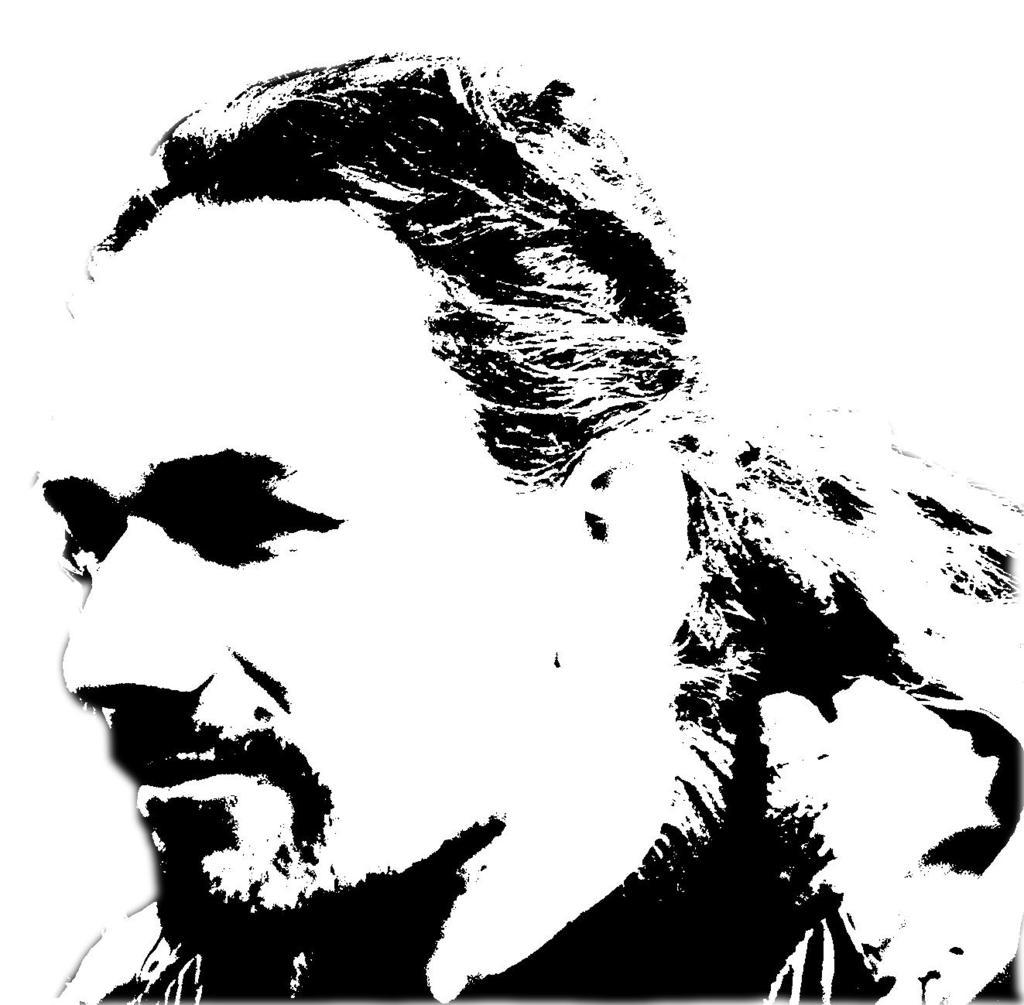What type of editing has been done to the image? The image is edited, but the specific type of editing is not mentioned in the facts. What is the main subject of the image? There is a black and white picture of a man in the image. How many kittens are playing in the trees in the image? There are no kittens or trees present in the image; it features a black and white picture of a man. 